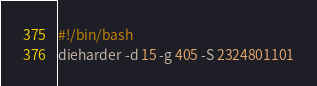Convert code to text. <code><loc_0><loc_0><loc_500><loc_500><_Bash_>#!/bin/bash
dieharder -d 15 -g 405 -S 2324801101
</code> 